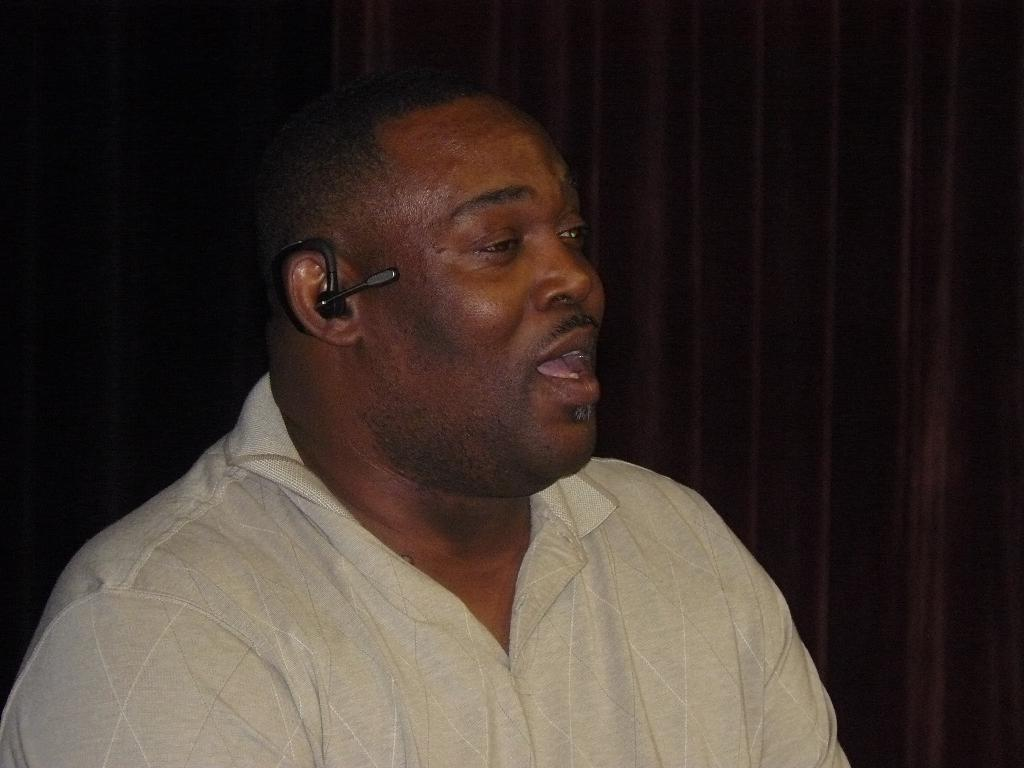What can be seen in the image? There is a person in the image. What is the person wearing in the image? The person is wearing a Bluetooth earphone. What else is visible in the image besides the person? There is a curtain visible in the image. Can you see the person's sister in the image? There is no mention of a sister in the image, so we cannot determine if the person's sister is present. 